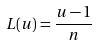<formula> <loc_0><loc_0><loc_500><loc_500>L ( u ) = \frac { u - 1 } { n }</formula> 